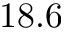Convert formula to latex. <formula><loc_0><loc_0><loc_500><loc_500>1 8 . 6</formula> 